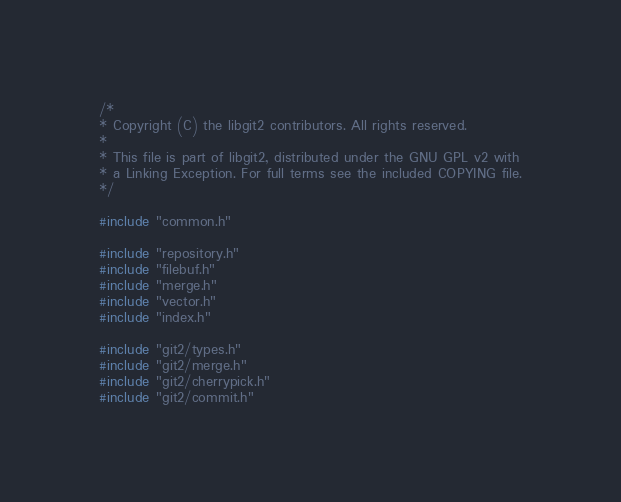Convert code to text. <code><loc_0><loc_0><loc_500><loc_500><_C_>/*
* Copyright (C) the libgit2 contributors. All rights reserved.
*
* This file is part of libgit2, distributed under the GNU GPL v2 with
* a Linking Exception. For full terms see the included COPYING file.
*/

#include "common.h"

#include "repository.h"
#include "filebuf.h"
#include "merge.h"
#include "vector.h"
#include "index.h"

#include "git2/types.h"
#include "git2/merge.h"
#include "git2/cherrypick.h"
#include "git2/commit.h"</code> 